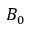<formula> <loc_0><loc_0><loc_500><loc_500>B _ { 0 }</formula> 